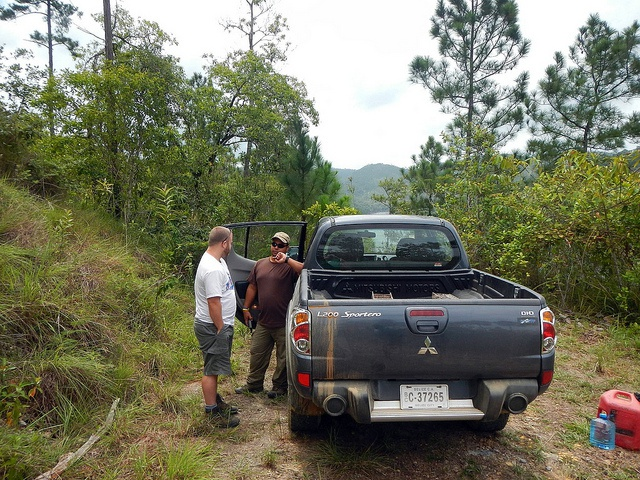Describe the objects in this image and their specific colors. I can see truck in lightblue, black, gray, and darkgray tones, people in lightblue, black, gray, olive, and lightgray tones, people in lightblue, black, maroon, and gray tones, and bottle in lightblue, gray, and teal tones in this image. 